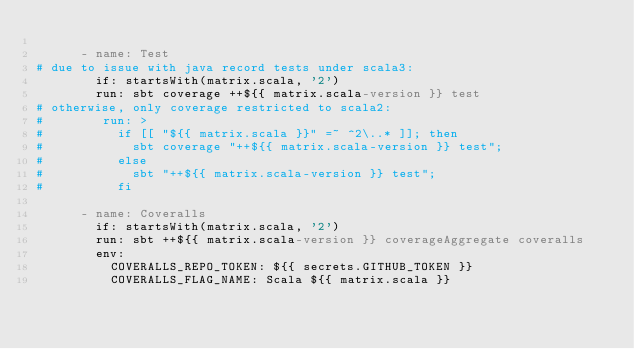<code> <loc_0><loc_0><loc_500><loc_500><_YAML_>
      - name: Test
# due to issue with java record tests under scala3:
        if: startsWith(matrix.scala, '2')
        run: sbt coverage ++${{ matrix.scala-version }} test
# otherwise, only coverage restricted to scala2:
#        run: >
#          if [[ "${{ matrix.scala }}" =~ ^2\..* ]]; then
#            sbt coverage "++${{ matrix.scala-version }} test";
#          else
#            sbt "++${{ matrix.scala-version }} test";
#          fi

      - name: Coveralls
        if: startsWith(matrix.scala, '2')
        run: sbt ++${{ matrix.scala-version }} coverageAggregate coveralls
        env:
          COVERALLS_REPO_TOKEN: ${{ secrets.GITHUB_TOKEN }}
          COVERALLS_FLAG_NAME: Scala ${{ matrix.scala }}
</code> 